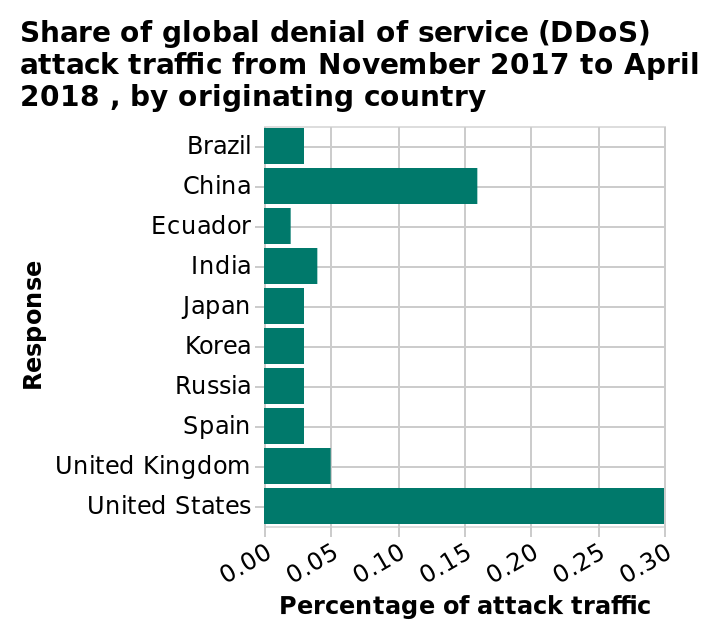<image>
Which country ranked second in terms of DDoS attack traffic?  China ranked second in terms of DDoS attack traffic. What are the minimum and maximum values on the x-axis? The minimum value on the x-axis is 0.00, and the maximum value is 0.30. What does the y-axis represent in the bar diagram? The y-axis represents the countries from which the denial of service (DDoS) attack traffic originated, starting from Brazil and ending at the United States. 